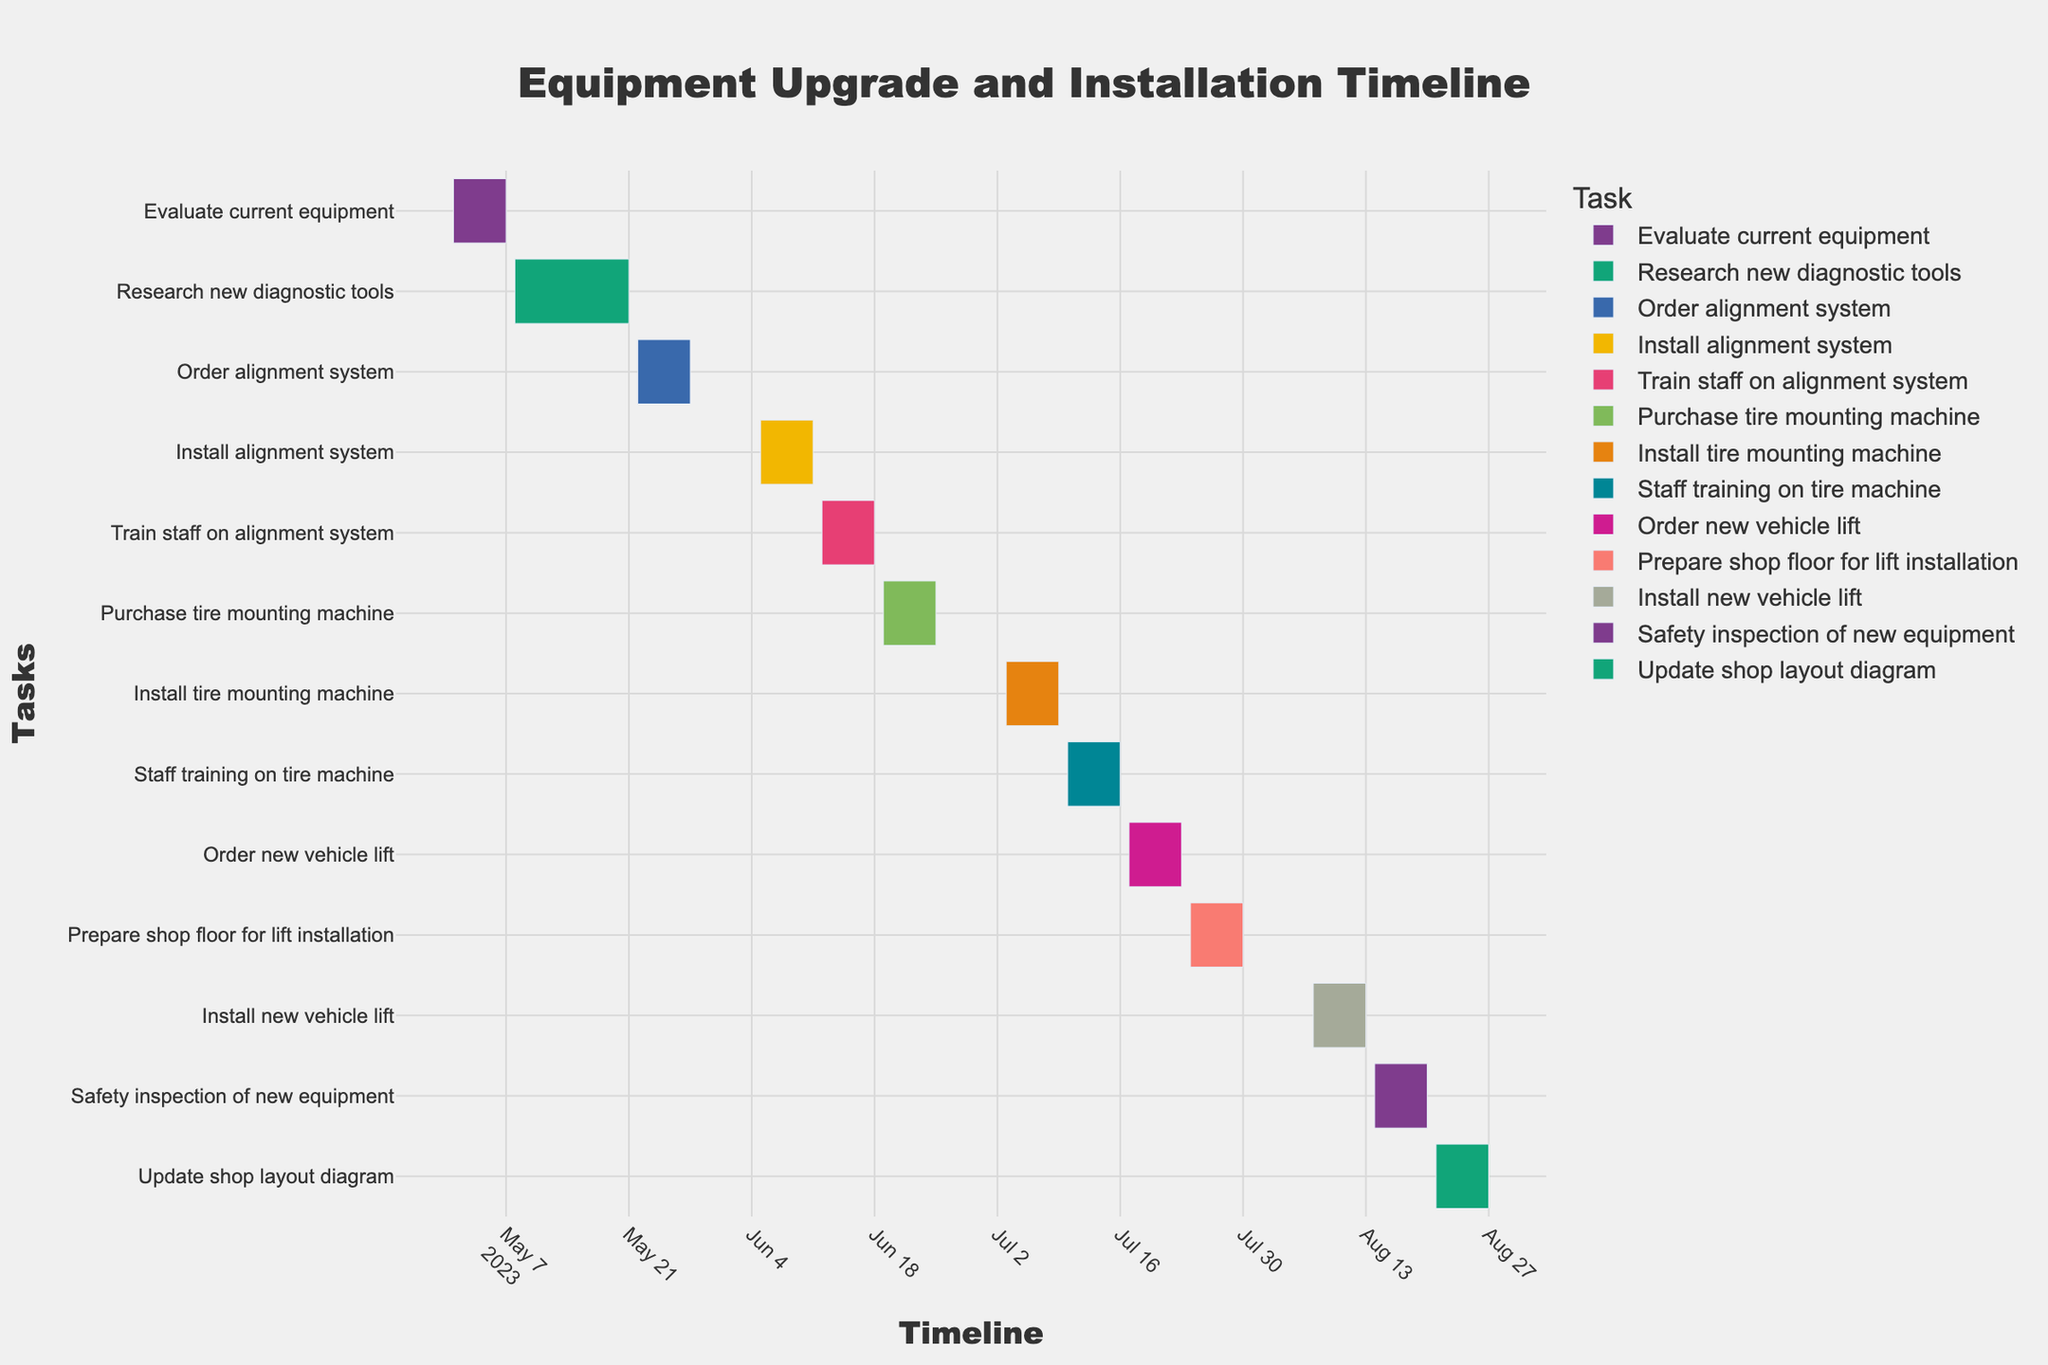what's the title of the figure? The title of the figure should be located at the top center and usually gives a summary of what the figure is about. By looking at the figure, you can read the title directly.
Answer: Equipment Upgrade and Installation Timeline how many tasks are displayed in the figure? Each task is displayed as a horizontal bar on the Gantt chart. By counting the number of horizontal bars, you can identify the total number of tasks.
Answer: 13 which task takes the longest period to complete? Review the length of each horizontal bar; the task with the longest bar spans the most days. In terms of duration, you need to count the number of days each bar covers.
Answer: Research new diagnostic tools how many tasks are scheduled to be completed in May 2023? Focus on the bars that start and end in May 2023. Looking at the dates on the x-axis and counting those bars will give you the number of tasks.
Answer: 3 which task starts immediately after "Install alignment system"? Identify the end date of "Install alignment system" and then find the task that starts on the very next calendar date. The task starting just after that end date is the one you are looking for.
Answer: Train staff on alignment system what's the total time span covered by all tasks in the figure? Find the earliest start date and the latest end date among all tasks. Subtract the earliest start date from the latest end date to get the overall time span.
Answer: 2023-05-01 to 2023-08-27 which task ends right before "Install tire mounting machine"? Locate the start date of "Install tire mounting machine". Identify the task with an end date that immediately precedes this start date.
Answer: Purchase tire mounting machine how many tasks are related to the alignment system? Tasks related to the alignment system have names that include the term "alignment system." Count these specific tasks.
Answer: 3 compare the duration of "Install new vehicle lift" and "Install tire mounting machine". Which one takes longer? Calculate the duration of each task by subtracting the start date from the end date. Compare the number of days each task takes.
Answer: Install new vehicle lift how many days does the "Safety inspection of new equipment" take to complete? Subtract the start date from the end date of this specific task to find the duration in days.
Answer: 7 days 